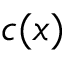<formula> <loc_0><loc_0><loc_500><loc_500>c ( x )</formula> 